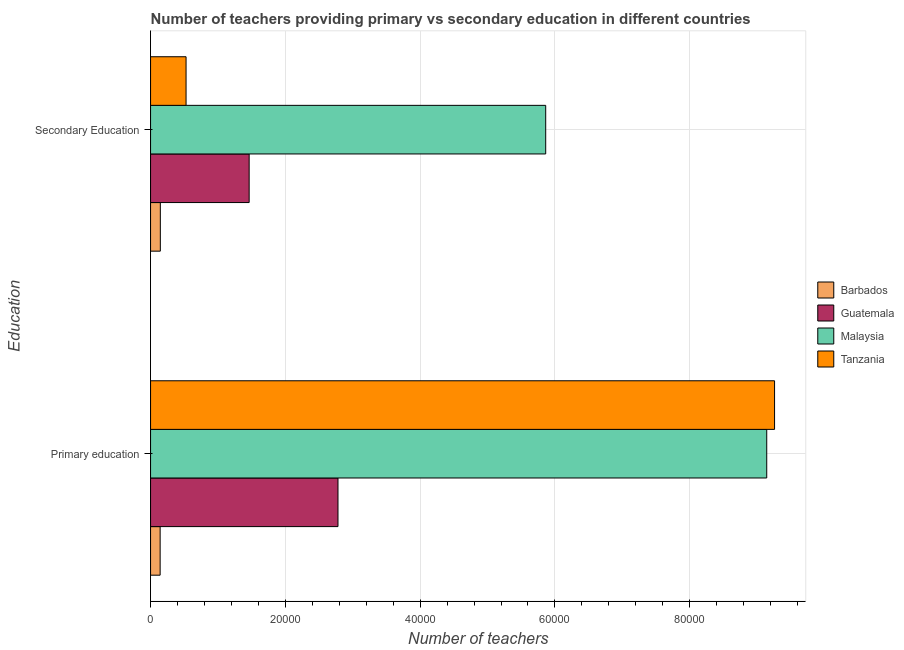How many different coloured bars are there?
Give a very brief answer. 4. How many groups of bars are there?
Make the answer very short. 2. Are the number of bars per tick equal to the number of legend labels?
Your answer should be very brief. Yes. How many bars are there on the 1st tick from the bottom?
Offer a very short reply. 4. What is the label of the 1st group of bars from the top?
Your response must be concise. Secondary Education. What is the number of primary teachers in Malaysia?
Provide a succinct answer. 9.14e+04. Across all countries, what is the maximum number of secondary teachers?
Your response must be concise. 5.86e+04. Across all countries, what is the minimum number of primary teachers?
Your answer should be compact. 1421. In which country was the number of secondary teachers maximum?
Offer a very short reply. Malaysia. In which country was the number of secondary teachers minimum?
Provide a succinct answer. Barbados. What is the total number of primary teachers in the graph?
Your response must be concise. 2.13e+05. What is the difference between the number of secondary teachers in Tanzania and that in Guatemala?
Your answer should be very brief. -9362. What is the difference between the number of secondary teachers in Tanzania and the number of primary teachers in Barbados?
Your response must be concise. 3846. What is the average number of primary teachers per country?
Provide a succinct answer. 5.33e+04. What is the difference between the number of primary teachers and number of secondary teachers in Barbados?
Keep it short and to the point. -28. In how many countries, is the number of secondary teachers greater than 88000 ?
Make the answer very short. 0. What is the ratio of the number of secondary teachers in Guatemala to that in Barbados?
Give a very brief answer. 10.1. In how many countries, is the number of secondary teachers greater than the average number of secondary teachers taken over all countries?
Offer a terse response. 1. What does the 2nd bar from the top in Primary education represents?
Provide a succinct answer. Malaysia. What does the 2nd bar from the bottom in Secondary Education represents?
Your answer should be compact. Guatemala. Are all the bars in the graph horizontal?
Your answer should be very brief. Yes. Does the graph contain grids?
Ensure brevity in your answer.  Yes. What is the title of the graph?
Offer a terse response. Number of teachers providing primary vs secondary education in different countries. What is the label or title of the X-axis?
Offer a very short reply. Number of teachers. What is the label or title of the Y-axis?
Keep it short and to the point. Education. What is the Number of teachers of Barbados in Primary education?
Your answer should be compact. 1421. What is the Number of teachers of Guatemala in Primary education?
Give a very brief answer. 2.78e+04. What is the Number of teachers of Malaysia in Primary education?
Ensure brevity in your answer.  9.14e+04. What is the Number of teachers in Tanzania in Primary education?
Keep it short and to the point. 9.26e+04. What is the Number of teachers of Barbados in Secondary Education?
Offer a terse response. 1449. What is the Number of teachers of Guatemala in Secondary Education?
Your response must be concise. 1.46e+04. What is the Number of teachers in Malaysia in Secondary Education?
Provide a short and direct response. 5.86e+04. What is the Number of teachers in Tanzania in Secondary Education?
Keep it short and to the point. 5267. Across all Education, what is the maximum Number of teachers in Barbados?
Provide a short and direct response. 1449. Across all Education, what is the maximum Number of teachers of Guatemala?
Offer a terse response. 2.78e+04. Across all Education, what is the maximum Number of teachers in Malaysia?
Make the answer very short. 9.14e+04. Across all Education, what is the maximum Number of teachers in Tanzania?
Keep it short and to the point. 9.26e+04. Across all Education, what is the minimum Number of teachers in Barbados?
Your answer should be very brief. 1421. Across all Education, what is the minimum Number of teachers in Guatemala?
Offer a very short reply. 1.46e+04. Across all Education, what is the minimum Number of teachers in Malaysia?
Your answer should be very brief. 5.86e+04. Across all Education, what is the minimum Number of teachers in Tanzania?
Provide a short and direct response. 5267. What is the total Number of teachers in Barbados in the graph?
Provide a succinct answer. 2870. What is the total Number of teachers of Guatemala in the graph?
Give a very brief answer. 4.24e+04. What is the total Number of teachers of Malaysia in the graph?
Provide a short and direct response. 1.50e+05. What is the total Number of teachers of Tanzania in the graph?
Make the answer very short. 9.79e+04. What is the difference between the Number of teachers in Guatemala in Primary education and that in Secondary Education?
Make the answer very short. 1.32e+04. What is the difference between the Number of teachers of Malaysia in Primary education and that in Secondary Education?
Your response must be concise. 3.28e+04. What is the difference between the Number of teachers of Tanzania in Primary education and that in Secondary Education?
Provide a succinct answer. 8.73e+04. What is the difference between the Number of teachers in Barbados in Primary education and the Number of teachers in Guatemala in Secondary Education?
Provide a succinct answer. -1.32e+04. What is the difference between the Number of teachers of Barbados in Primary education and the Number of teachers of Malaysia in Secondary Education?
Make the answer very short. -5.72e+04. What is the difference between the Number of teachers of Barbados in Primary education and the Number of teachers of Tanzania in Secondary Education?
Ensure brevity in your answer.  -3846. What is the difference between the Number of teachers in Guatemala in Primary education and the Number of teachers in Malaysia in Secondary Education?
Keep it short and to the point. -3.08e+04. What is the difference between the Number of teachers in Guatemala in Primary education and the Number of teachers in Tanzania in Secondary Education?
Your answer should be very brief. 2.25e+04. What is the difference between the Number of teachers of Malaysia in Primary education and the Number of teachers of Tanzania in Secondary Education?
Ensure brevity in your answer.  8.62e+04. What is the average Number of teachers of Barbados per Education?
Provide a short and direct response. 1435. What is the average Number of teachers of Guatemala per Education?
Make the answer very short. 2.12e+04. What is the average Number of teachers of Malaysia per Education?
Provide a succinct answer. 7.50e+04. What is the average Number of teachers in Tanzania per Education?
Offer a very short reply. 4.89e+04. What is the difference between the Number of teachers in Barbados and Number of teachers in Guatemala in Primary education?
Provide a succinct answer. -2.64e+04. What is the difference between the Number of teachers of Barbados and Number of teachers of Malaysia in Primary education?
Offer a terse response. -9.00e+04. What is the difference between the Number of teachers in Barbados and Number of teachers in Tanzania in Primary education?
Your answer should be very brief. -9.12e+04. What is the difference between the Number of teachers of Guatemala and Number of teachers of Malaysia in Primary education?
Offer a very short reply. -6.36e+04. What is the difference between the Number of teachers of Guatemala and Number of teachers of Tanzania in Primary education?
Your answer should be compact. -6.48e+04. What is the difference between the Number of teachers of Malaysia and Number of teachers of Tanzania in Primary education?
Your answer should be compact. -1162. What is the difference between the Number of teachers of Barbados and Number of teachers of Guatemala in Secondary Education?
Make the answer very short. -1.32e+04. What is the difference between the Number of teachers in Barbados and Number of teachers in Malaysia in Secondary Education?
Your response must be concise. -5.72e+04. What is the difference between the Number of teachers of Barbados and Number of teachers of Tanzania in Secondary Education?
Offer a very short reply. -3818. What is the difference between the Number of teachers in Guatemala and Number of teachers in Malaysia in Secondary Education?
Your answer should be very brief. -4.40e+04. What is the difference between the Number of teachers in Guatemala and Number of teachers in Tanzania in Secondary Education?
Your answer should be compact. 9362. What is the difference between the Number of teachers of Malaysia and Number of teachers of Tanzania in Secondary Education?
Provide a short and direct response. 5.34e+04. What is the ratio of the Number of teachers of Barbados in Primary education to that in Secondary Education?
Make the answer very short. 0.98. What is the ratio of the Number of teachers of Guatemala in Primary education to that in Secondary Education?
Keep it short and to the point. 1.9. What is the ratio of the Number of teachers of Malaysia in Primary education to that in Secondary Education?
Give a very brief answer. 1.56. What is the ratio of the Number of teachers of Tanzania in Primary education to that in Secondary Education?
Ensure brevity in your answer.  17.58. What is the difference between the highest and the second highest Number of teachers of Guatemala?
Ensure brevity in your answer.  1.32e+04. What is the difference between the highest and the second highest Number of teachers of Malaysia?
Provide a succinct answer. 3.28e+04. What is the difference between the highest and the second highest Number of teachers of Tanzania?
Make the answer very short. 8.73e+04. What is the difference between the highest and the lowest Number of teachers of Guatemala?
Your answer should be very brief. 1.32e+04. What is the difference between the highest and the lowest Number of teachers in Malaysia?
Ensure brevity in your answer.  3.28e+04. What is the difference between the highest and the lowest Number of teachers of Tanzania?
Make the answer very short. 8.73e+04. 